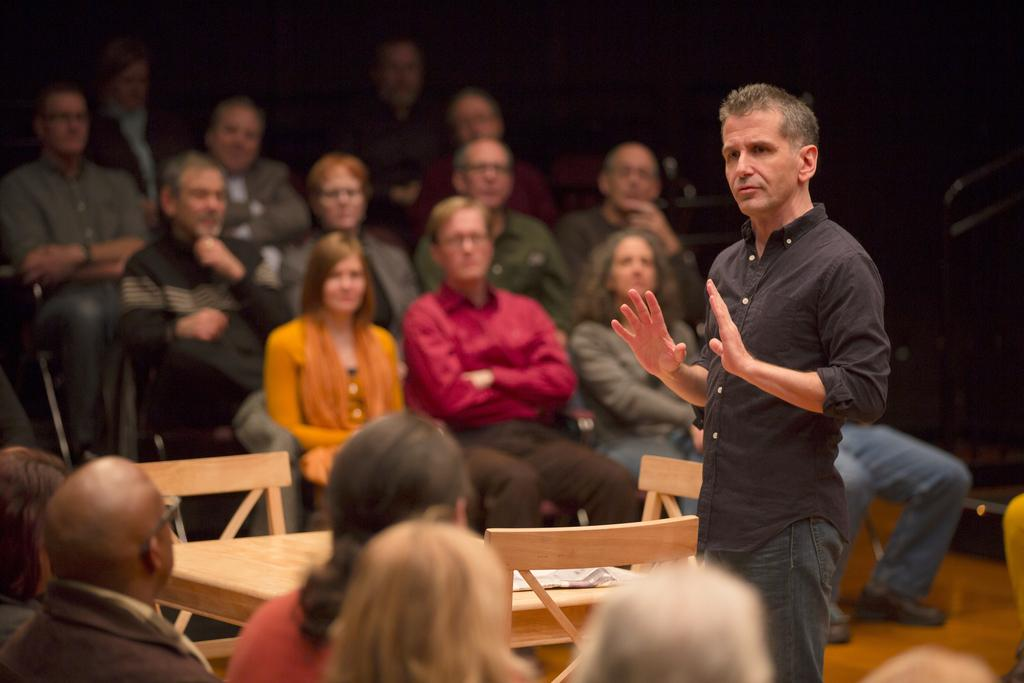What are the people in the image doing? The people in the image are sitting on chairs. What is the man in the image doing? The man is standing in front of the seated people. What object can be seen on the table in the image? There is a paper on the table. What is the color of the background in the image? The background of the image is black in color. What type of skin condition can be seen on the man's face in the image? There is no skin condition visible on the man's face in the image. Can you describe the tramp that is sitting next to the table in the image? There is no tramp present in the image; only people sitting on chairs, a standing man, a table, and a paper are visible. 